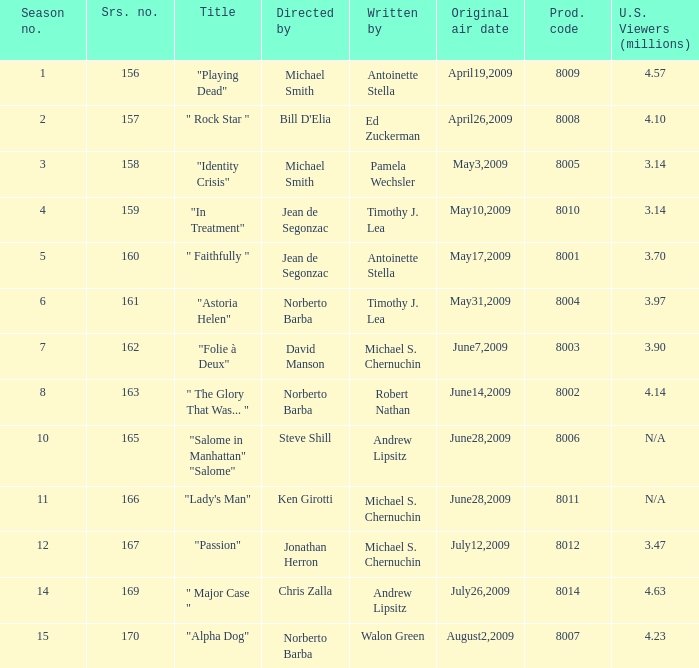Who are the writers when the production code is 8011? Michael S. Chernuchin. 